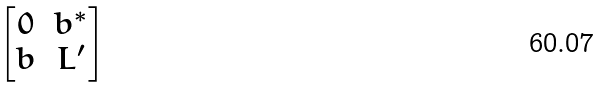<formula> <loc_0><loc_0><loc_500><loc_500>\begin{bmatrix} 0 & b ^ { * } \\ b & L ^ { \prime } \end{bmatrix}</formula> 